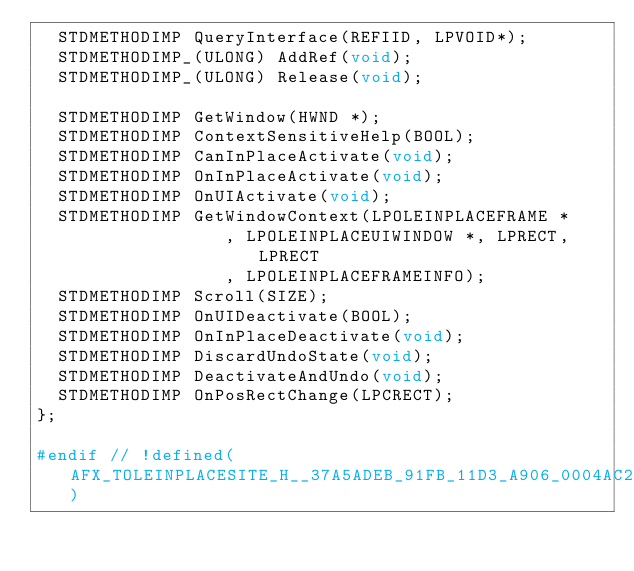<code> <loc_0><loc_0><loc_500><loc_500><_C_>  STDMETHODIMP QueryInterface(REFIID, LPVOID*);
  STDMETHODIMP_(ULONG) AddRef(void);
  STDMETHODIMP_(ULONG) Release(void);

  STDMETHODIMP GetWindow(HWND *);
  STDMETHODIMP ContextSensitiveHelp(BOOL);
  STDMETHODIMP CanInPlaceActivate(void);
  STDMETHODIMP OnInPlaceActivate(void);
  STDMETHODIMP OnUIActivate(void);
  STDMETHODIMP GetWindowContext(LPOLEINPLACEFRAME *
                  , LPOLEINPLACEUIWINDOW *, LPRECT, LPRECT
                  , LPOLEINPLACEFRAMEINFO);
  STDMETHODIMP Scroll(SIZE);
  STDMETHODIMP OnUIDeactivate(BOOL);
  STDMETHODIMP OnInPlaceDeactivate(void);
  STDMETHODIMP DiscardUndoState(void);
  STDMETHODIMP DeactivateAndUndo(void);
  STDMETHODIMP OnPosRectChange(LPCRECT);
};

#endif // !defined(AFX_TOLEINPLACESITE_H__37A5ADEB_91FB_11D3_A906_0004AC252223__INCLUDED_)
</code> 